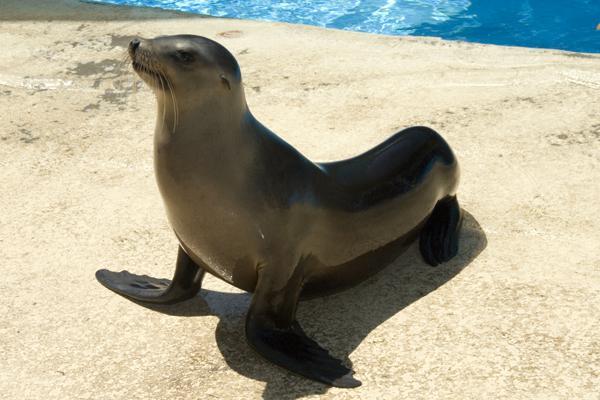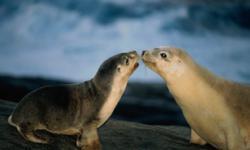The first image is the image on the left, the second image is the image on the right. Examine the images to the left and right. Is the description "An image shows exactly one seal on a manmade structure next to a blue pool." accurate? Answer yes or no. Yes. The first image is the image on the left, the second image is the image on the right. Considering the images on both sides, is "There are two seals in total." valid? Answer yes or no. No. 